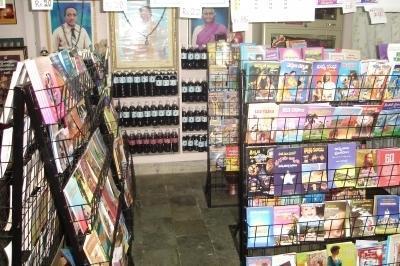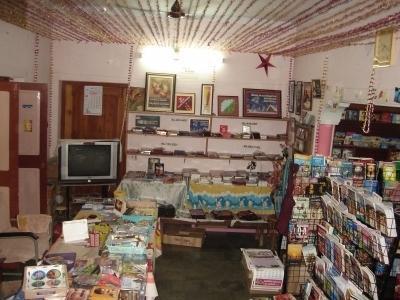The first image is the image on the left, the second image is the image on the right. Considering the images on both sides, is "There are two bookstores, with bright light visible through the windows of at least one." valid? Answer yes or no. Yes. The first image is the image on the left, the second image is the image on the right. Considering the images on both sides, is "At least one image shows a bookshop that uses royal blue in its color scheme." valid? Answer yes or no. No. 